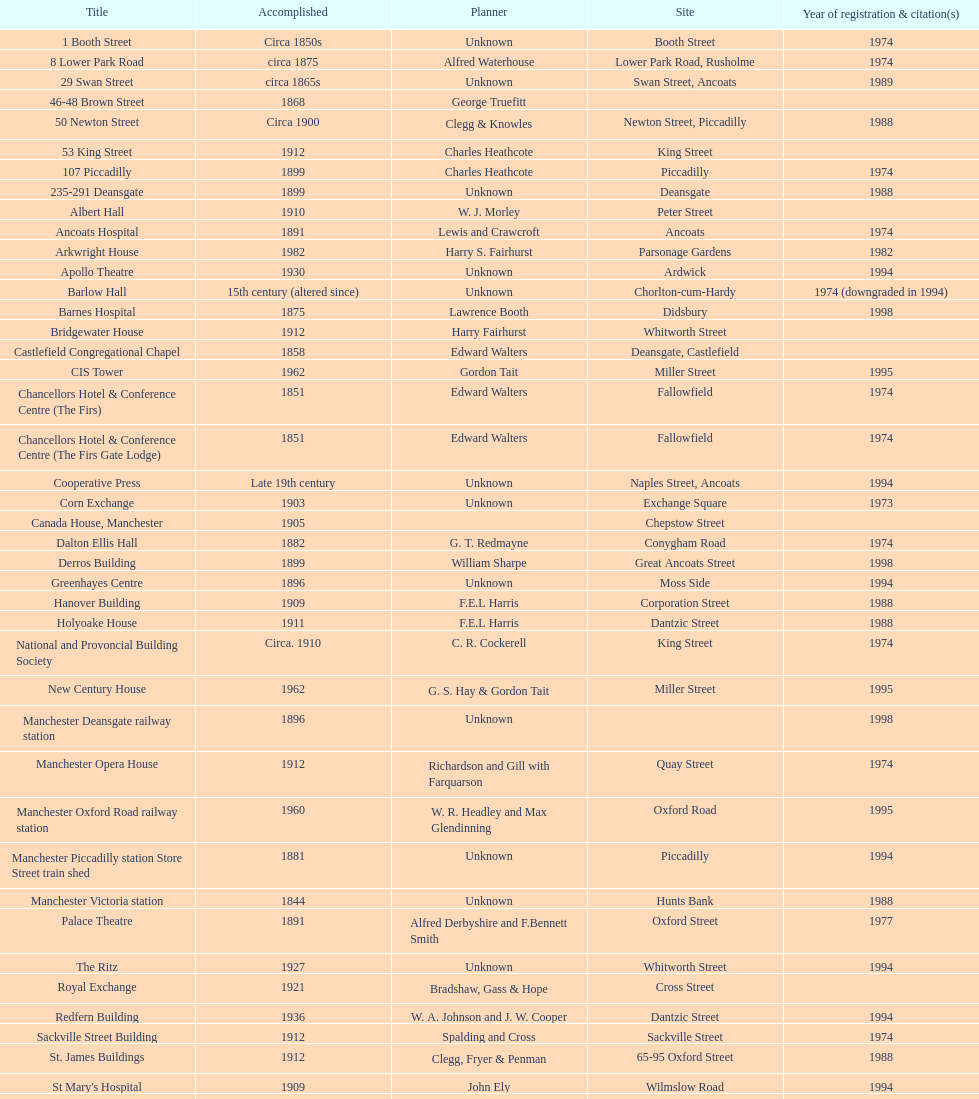What is the street of the only building listed in 1989? Swan Street. Parse the full table. {'header': ['Title', 'Accomplished', 'Planner', 'Site', 'Year of registration & citation(s)'], 'rows': [['1 Booth Street', 'Circa 1850s', 'Unknown', 'Booth Street', '1974'], ['8 Lower Park Road', 'circa 1875', 'Alfred Waterhouse', 'Lower Park Road, Rusholme', '1974'], ['29 Swan Street', 'circa 1865s', 'Unknown', 'Swan Street, Ancoats', '1989'], ['46-48 Brown Street', '1868', 'George Truefitt', '', ''], ['50 Newton Street', 'Circa 1900', 'Clegg & Knowles', 'Newton Street, Piccadilly', '1988'], ['53 King Street', '1912', 'Charles Heathcote', 'King Street', ''], ['107 Piccadilly', '1899', 'Charles Heathcote', 'Piccadilly', '1974'], ['235-291 Deansgate', '1899', 'Unknown', 'Deansgate', '1988'], ['Albert Hall', '1910', 'W. J. Morley', 'Peter Street', ''], ['Ancoats Hospital', '1891', 'Lewis and Crawcroft', 'Ancoats', '1974'], ['Arkwright House', '1982', 'Harry S. Fairhurst', 'Parsonage Gardens', '1982'], ['Apollo Theatre', '1930', 'Unknown', 'Ardwick', '1994'], ['Barlow Hall', '15th century (altered since)', 'Unknown', 'Chorlton-cum-Hardy', '1974 (downgraded in 1994)'], ['Barnes Hospital', '1875', 'Lawrence Booth', 'Didsbury', '1998'], ['Bridgewater House', '1912', 'Harry Fairhurst', 'Whitworth Street', ''], ['Castlefield Congregational Chapel', '1858', 'Edward Walters', 'Deansgate, Castlefield', ''], ['CIS Tower', '1962', 'Gordon Tait', 'Miller Street', '1995'], ['Chancellors Hotel & Conference Centre (The Firs)', '1851', 'Edward Walters', 'Fallowfield', '1974'], ['Chancellors Hotel & Conference Centre (The Firs Gate Lodge)', '1851', 'Edward Walters', 'Fallowfield', '1974'], ['Cooperative Press', 'Late 19th century', 'Unknown', 'Naples Street, Ancoats', '1994'], ['Corn Exchange', '1903', 'Unknown', 'Exchange Square', '1973'], ['Canada House, Manchester', '1905', '', 'Chepstow Street', ''], ['Dalton Ellis Hall', '1882', 'G. T. Redmayne', 'Conygham Road', '1974'], ['Derros Building', '1899', 'William Sharpe', 'Great Ancoats Street', '1998'], ['Greenhayes Centre', '1896', 'Unknown', 'Moss Side', '1994'], ['Hanover Building', '1909', 'F.E.L Harris', 'Corporation Street', '1988'], ['Holyoake House', '1911', 'F.E.L Harris', 'Dantzic Street', '1988'], ['National and Provoncial Building Society', 'Circa. 1910', 'C. R. Cockerell', 'King Street', '1974'], ['New Century House', '1962', 'G. S. Hay & Gordon Tait', 'Miller Street', '1995'], ['Manchester Deansgate railway station', '1896', 'Unknown', '', '1998'], ['Manchester Opera House', '1912', 'Richardson and Gill with Farquarson', 'Quay Street', '1974'], ['Manchester Oxford Road railway station', '1960', 'W. R. Headley and Max Glendinning', 'Oxford Road', '1995'], ['Manchester Piccadilly station Store Street train shed', '1881', 'Unknown', 'Piccadilly', '1994'], ['Manchester Victoria station', '1844', 'Unknown', 'Hunts Bank', '1988'], ['Palace Theatre', '1891', 'Alfred Derbyshire and F.Bennett Smith', 'Oxford Street', '1977'], ['The Ritz', '1927', 'Unknown', 'Whitworth Street', '1994'], ['Royal Exchange', '1921', 'Bradshaw, Gass & Hope', 'Cross Street', ''], ['Redfern Building', '1936', 'W. A. Johnson and J. W. Cooper', 'Dantzic Street', '1994'], ['Sackville Street Building', '1912', 'Spalding and Cross', 'Sackville Street', '1974'], ['St. James Buildings', '1912', 'Clegg, Fryer & Penman', '65-95 Oxford Street', '1988'], ["St Mary's Hospital", '1909', 'John Ely', 'Wilmslow Road', '1994'], ['Samuel Alexander Building', '1919', 'Percy Scott Worthington', 'Oxford Road', '2010'], ['Ship Canal House', '1927', 'Harry S. Fairhurst', 'King Street', '1982'], ['Smithfield Market Hall', '1857', 'Unknown', 'Swan Street, Ancoats', '1973'], ['Strangeways Gaol Gatehouse', '1868', 'Alfred Waterhouse', 'Sherborne Street', '1974'], ['Strangeways Prison ventilation and watch tower', '1868', 'Alfred Waterhouse', 'Sherborne Street', '1974'], ['Theatre Royal', '1845', 'Irwin and Chester', 'Peter Street', '1974'], ['Toast Rack', '1960', 'L. C. Howitt', 'Fallowfield', '1999'], ['The Old Wellington Inn', 'Mid-16th century', 'Unknown', 'Shambles Square', '1952'], ['Whitworth Park Mansions', 'Circa 1840s', 'Unknown', 'Whitworth Park', '1974']]} 